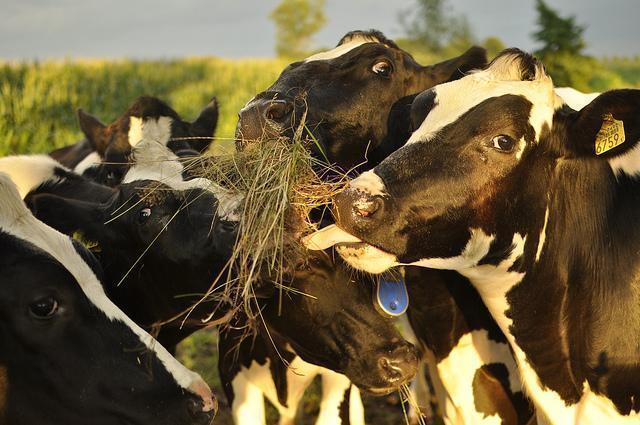What are the animals eating?
Select the accurate answer and provide justification: `Answer: choice
Rationale: srationale.`
Options: Grass, dirt, hay, food. Answer: grass.
Rationale: There is green grass hanging out of their mouths. 